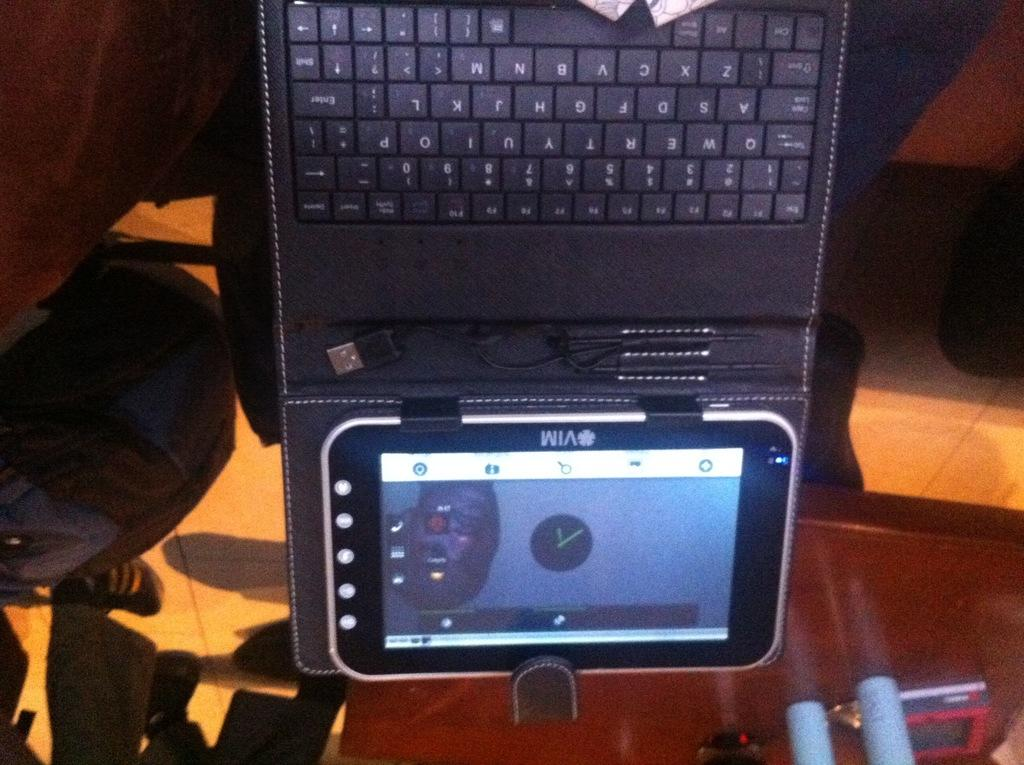<image>
Share a concise interpretation of the image provided. A VIM tablet is attached to a black keyboard and shows the time in the middle of the screen. 